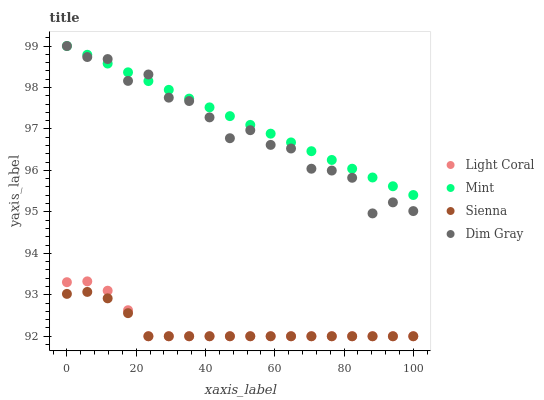Does Sienna have the minimum area under the curve?
Answer yes or no. Yes. Does Mint have the maximum area under the curve?
Answer yes or no. Yes. Does Dim Gray have the minimum area under the curve?
Answer yes or no. No. Does Dim Gray have the maximum area under the curve?
Answer yes or no. No. Is Mint the smoothest?
Answer yes or no. Yes. Is Dim Gray the roughest?
Answer yes or no. Yes. Is Sienna the smoothest?
Answer yes or no. No. Is Sienna the roughest?
Answer yes or no. No. Does Light Coral have the lowest value?
Answer yes or no. Yes. Does Dim Gray have the lowest value?
Answer yes or no. No. Does Mint have the highest value?
Answer yes or no. Yes. Does Sienna have the highest value?
Answer yes or no. No. Is Sienna less than Mint?
Answer yes or no. Yes. Is Mint greater than Sienna?
Answer yes or no. Yes. Does Dim Gray intersect Mint?
Answer yes or no. Yes. Is Dim Gray less than Mint?
Answer yes or no. No. Is Dim Gray greater than Mint?
Answer yes or no. No. Does Sienna intersect Mint?
Answer yes or no. No. 